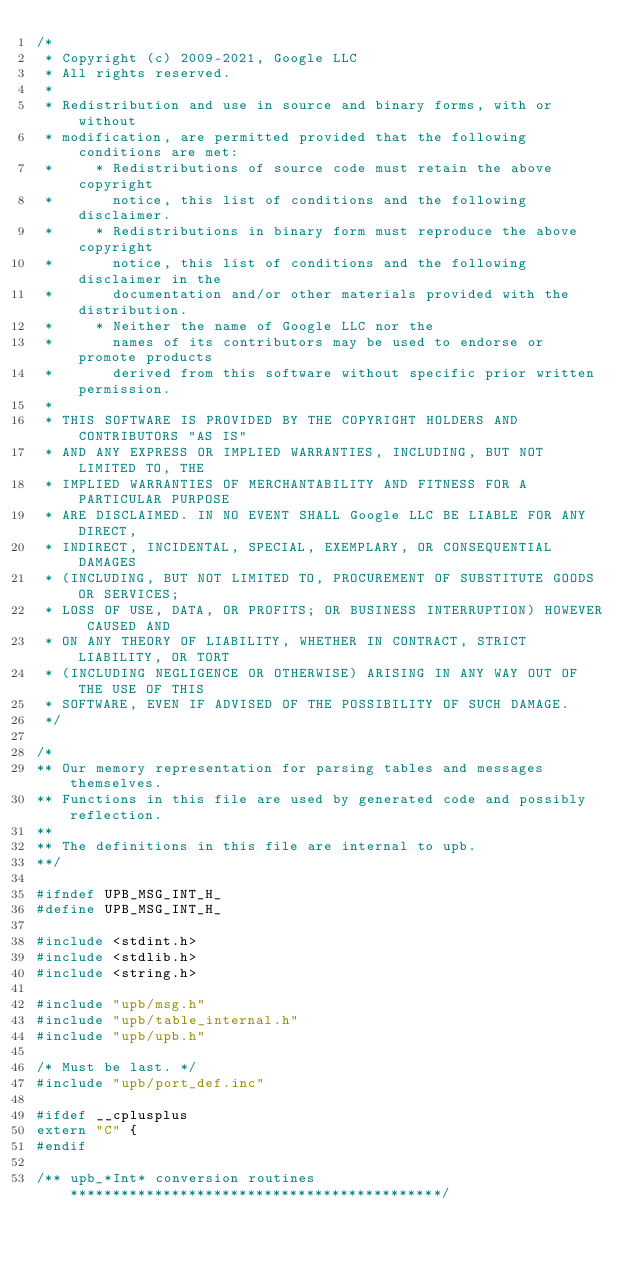<code> <loc_0><loc_0><loc_500><loc_500><_C_>/*
 * Copyright (c) 2009-2021, Google LLC
 * All rights reserved.
 *
 * Redistribution and use in source and binary forms, with or without
 * modification, are permitted provided that the following conditions are met:
 *     * Redistributions of source code must retain the above copyright
 *       notice, this list of conditions and the following disclaimer.
 *     * Redistributions in binary form must reproduce the above copyright
 *       notice, this list of conditions and the following disclaimer in the
 *       documentation and/or other materials provided with the distribution.
 *     * Neither the name of Google LLC nor the
 *       names of its contributors may be used to endorse or promote products
 *       derived from this software without specific prior written permission.
 *
 * THIS SOFTWARE IS PROVIDED BY THE COPYRIGHT HOLDERS AND CONTRIBUTORS "AS IS"
 * AND ANY EXPRESS OR IMPLIED WARRANTIES, INCLUDING, BUT NOT LIMITED TO, THE
 * IMPLIED WARRANTIES OF MERCHANTABILITY AND FITNESS FOR A PARTICULAR PURPOSE
 * ARE DISCLAIMED. IN NO EVENT SHALL Google LLC BE LIABLE FOR ANY DIRECT,
 * INDIRECT, INCIDENTAL, SPECIAL, EXEMPLARY, OR CONSEQUENTIAL DAMAGES
 * (INCLUDING, BUT NOT LIMITED TO, PROCUREMENT OF SUBSTITUTE GOODS OR SERVICES;
 * LOSS OF USE, DATA, OR PROFITS; OR BUSINESS INTERRUPTION) HOWEVER CAUSED AND
 * ON ANY THEORY OF LIABILITY, WHETHER IN CONTRACT, STRICT LIABILITY, OR TORT
 * (INCLUDING NEGLIGENCE OR OTHERWISE) ARISING IN ANY WAY OUT OF THE USE OF THIS
 * SOFTWARE, EVEN IF ADVISED OF THE POSSIBILITY OF SUCH DAMAGE.
 */

/*
** Our memory representation for parsing tables and messages themselves.
** Functions in this file are used by generated code and possibly reflection.
**
** The definitions in this file are internal to upb.
**/

#ifndef UPB_MSG_INT_H_
#define UPB_MSG_INT_H_

#include <stdint.h>
#include <stdlib.h>
#include <string.h>

#include "upb/msg.h"
#include "upb/table_internal.h"
#include "upb/upb.h"

/* Must be last. */
#include "upb/port_def.inc"

#ifdef __cplusplus
extern "C" {
#endif

/** upb_*Int* conversion routines ********************************************/
</code> 